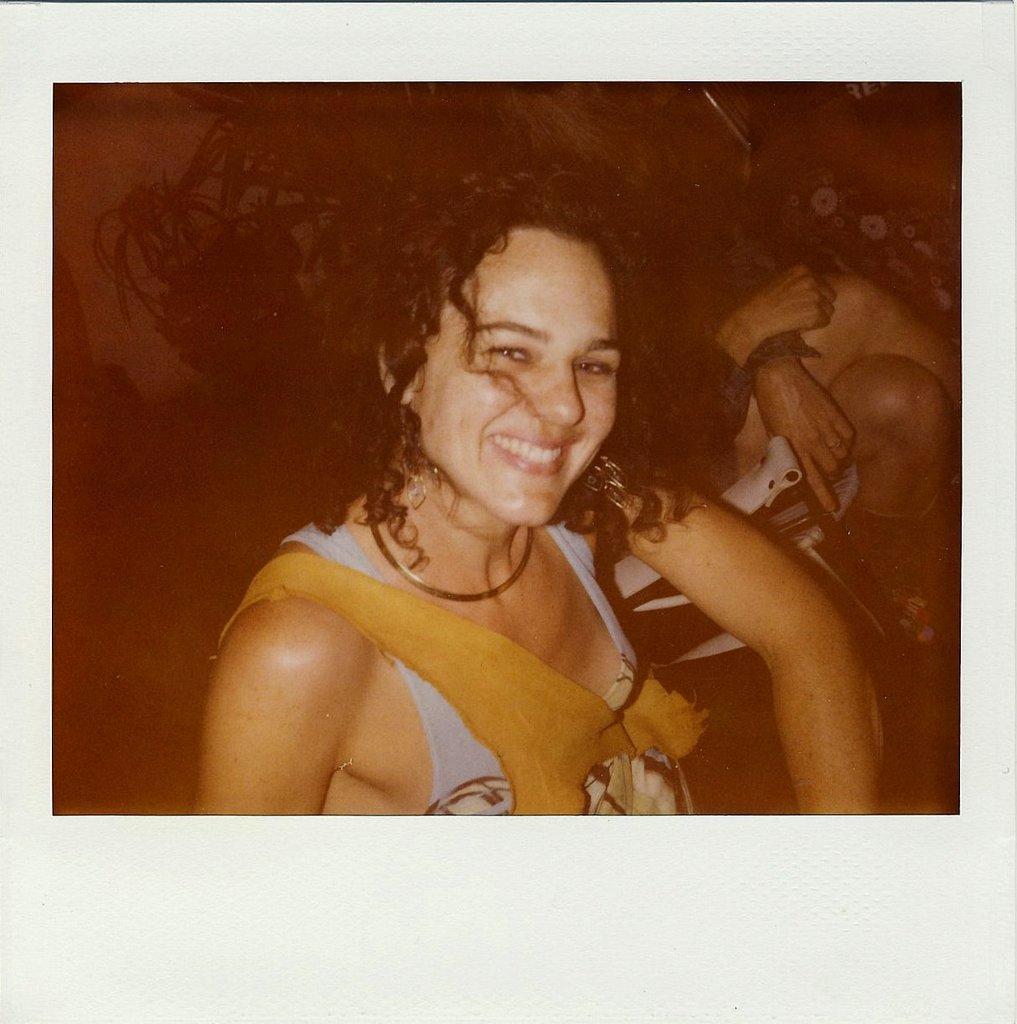Please provide a concise description of this image. In this image we can see this person is sitting here and smiling. The background of the image is dark where we can see a person sitting on a chair and we can see the flower pots. 